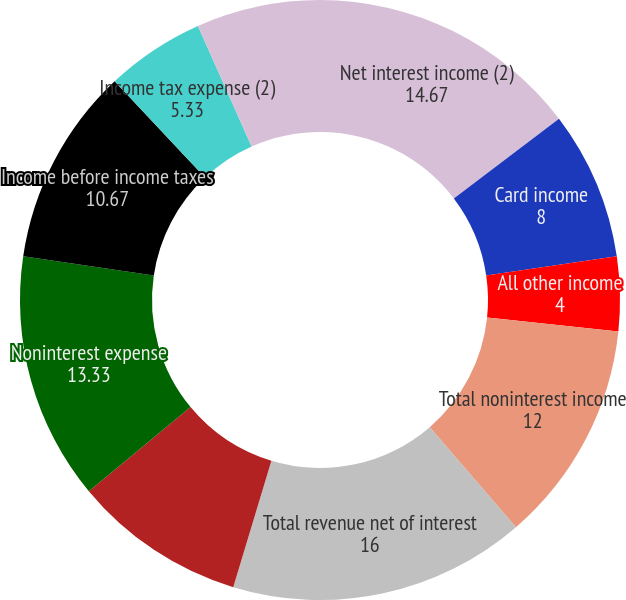<chart> <loc_0><loc_0><loc_500><loc_500><pie_chart><fcel>Net interest income (2)<fcel>Card income<fcel>All other income<fcel>Total noninterest income<fcel>Total revenue net of interest<fcel>Provision for credit losses<fcel>Noninterest expense<fcel>Income before income taxes<fcel>Income tax expense (2)<fcel>Net income<nl><fcel>14.67%<fcel>8.0%<fcel>4.0%<fcel>12.0%<fcel>16.0%<fcel>9.33%<fcel>13.33%<fcel>10.67%<fcel>5.33%<fcel>6.67%<nl></chart> 